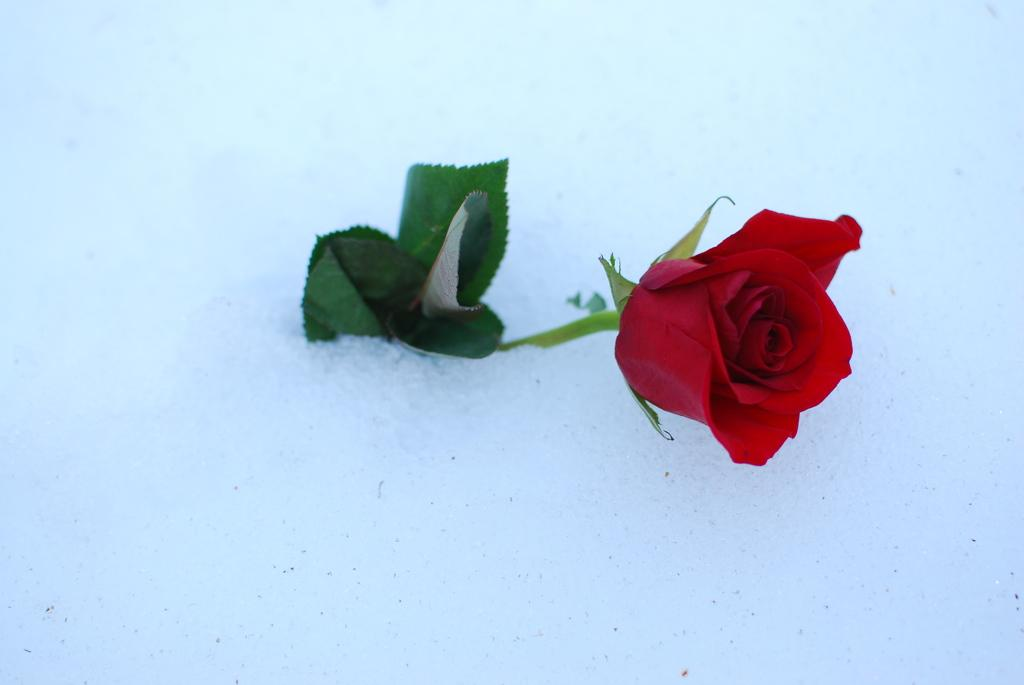What type of flower is present in the image? There is a beautiful rose flower in the image. What is the weather condition in the image? The image contains snow, which suggests a cold or wintry environment. What type of vacation is being enjoyed in the image? There is no indication of a vacation in the image, as it only features a rose flower and snow. 